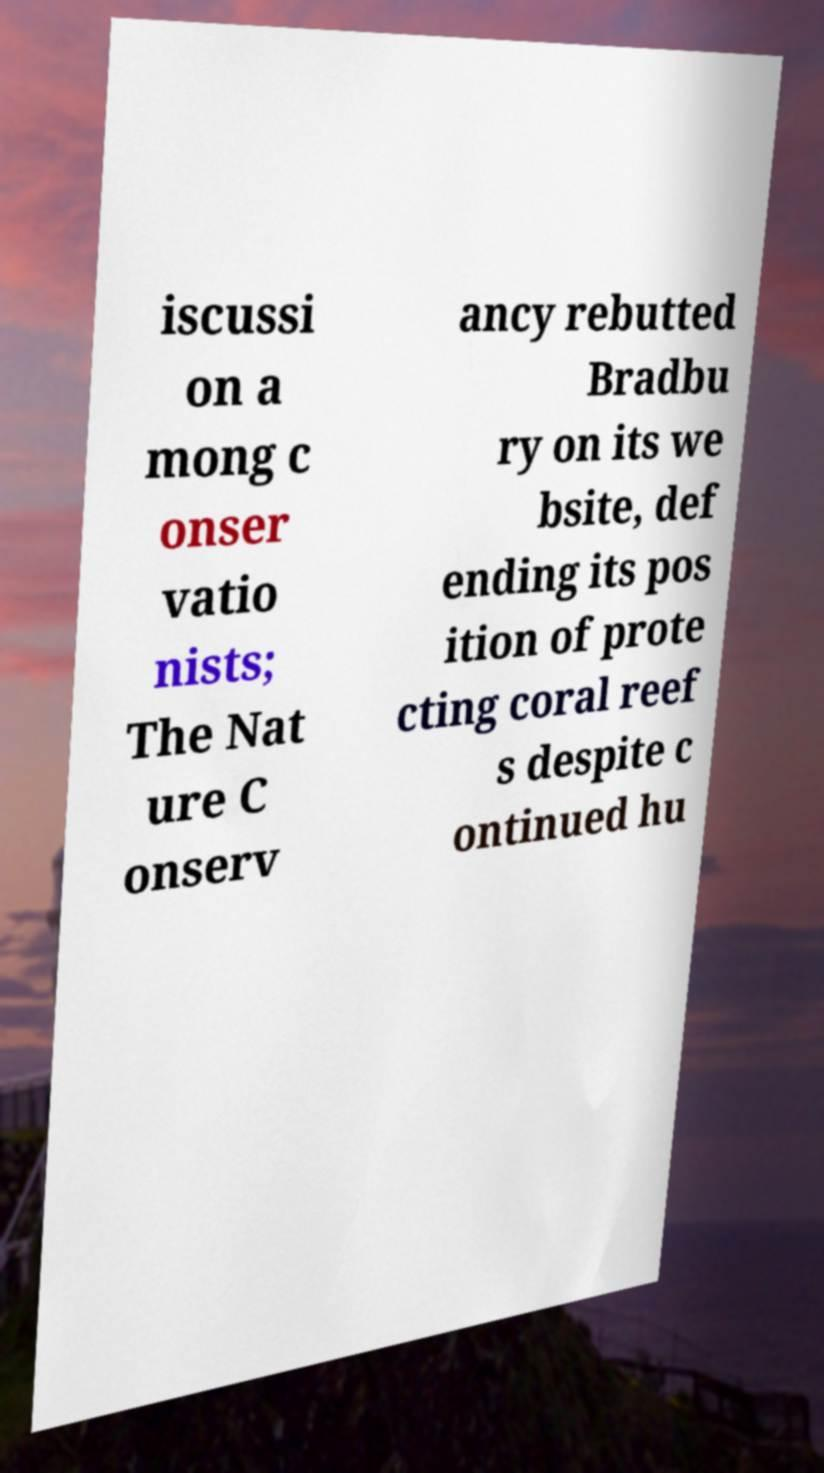Can you read and provide the text displayed in the image?This photo seems to have some interesting text. Can you extract and type it out for me? iscussi on a mong c onser vatio nists; The Nat ure C onserv ancy rebutted Bradbu ry on its we bsite, def ending its pos ition of prote cting coral reef s despite c ontinued hu 